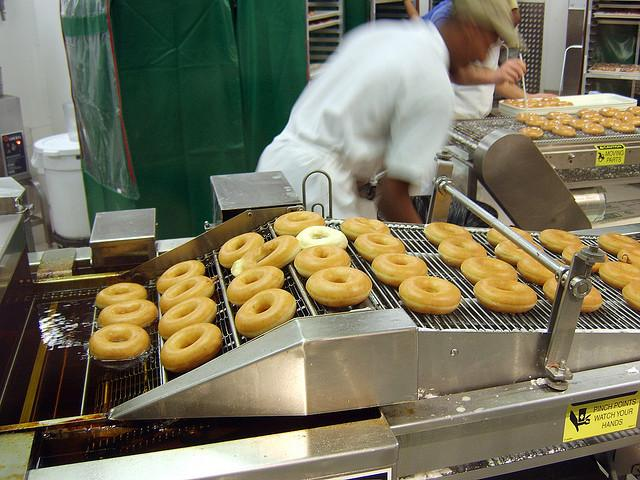What type of job are the men doing? Please explain your reasoning. baking. The people are making donuts. 